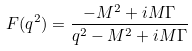<formula> <loc_0><loc_0><loc_500><loc_500>F ( q ^ { 2 } ) = \frac { - M ^ { 2 } + i M \Gamma } { q ^ { 2 } - M ^ { 2 } + i M \Gamma }</formula> 